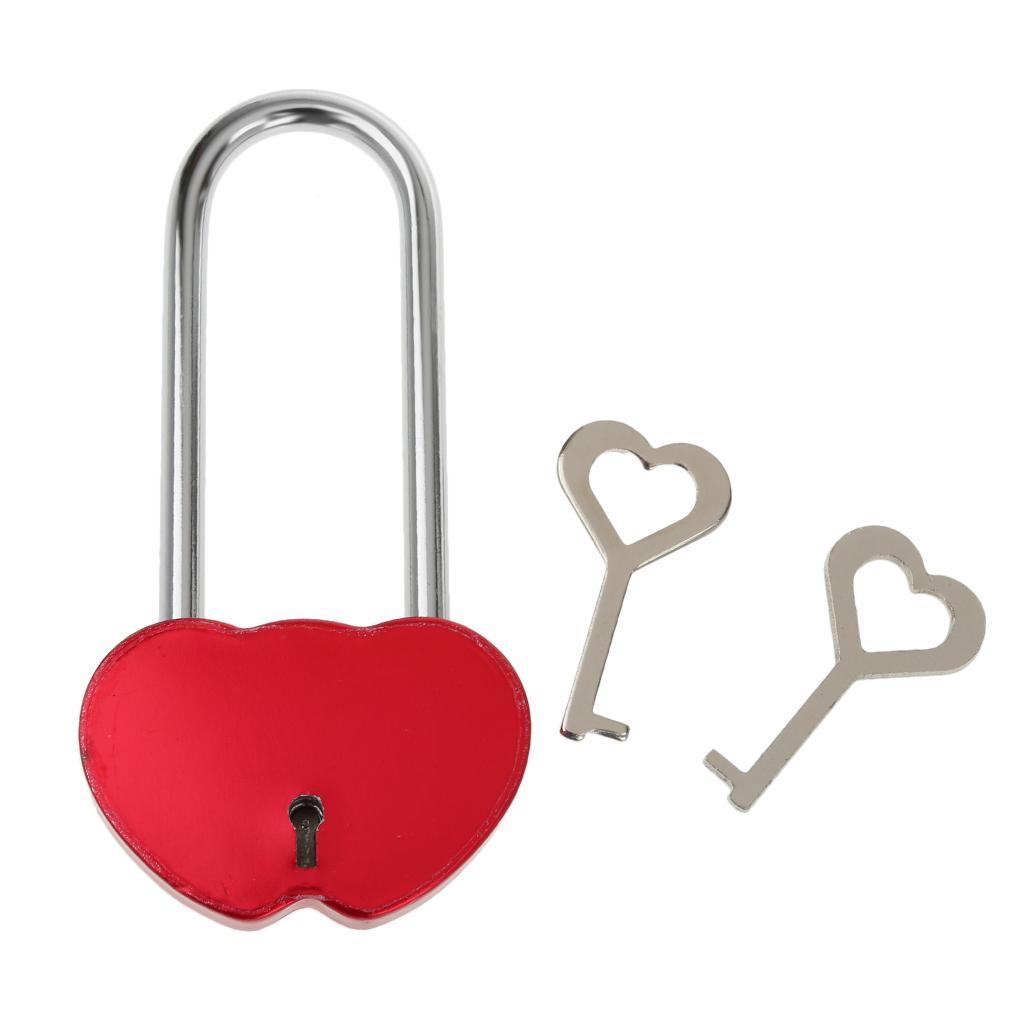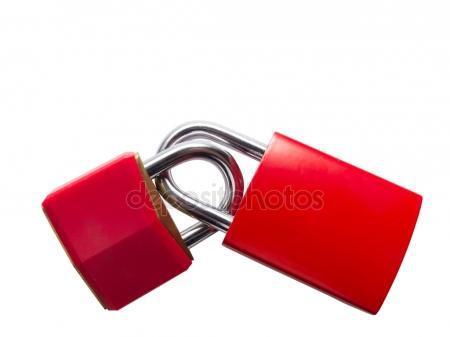The first image is the image on the left, the second image is the image on the right. Examine the images to the left and right. Is the description "At least two of the locks are combination locks." accurate? Answer yes or no. No. The first image is the image on the left, the second image is the image on the right. Evaluate the accuracy of this statement regarding the images: "In one image there is a pair of red locks that are in the closed position.". Is it true? Answer yes or no. Yes. 